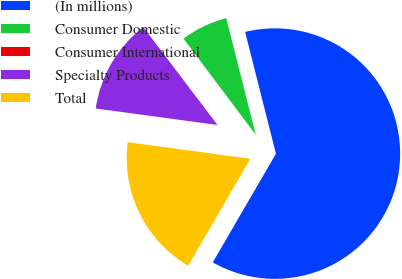<chart> <loc_0><loc_0><loc_500><loc_500><pie_chart><fcel>(In millions)<fcel>Consumer Domestic<fcel>Consumer International<fcel>Specialty Products<fcel>Total<nl><fcel>62.33%<fcel>6.31%<fcel>0.08%<fcel>12.53%<fcel>18.76%<nl></chart> 